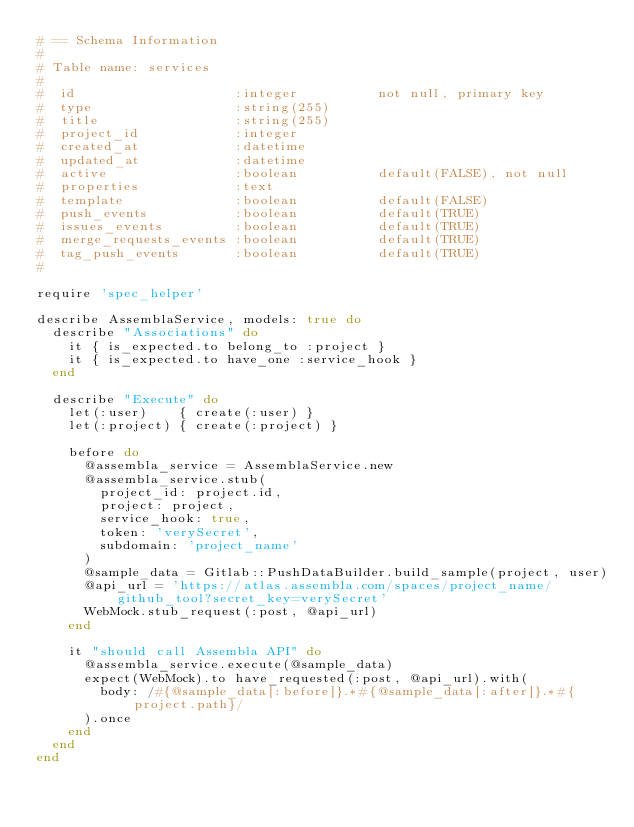<code> <loc_0><loc_0><loc_500><loc_500><_Ruby_># == Schema Information
#
# Table name: services
#
#  id                    :integer          not null, primary key
#  type                  :string(255)
#  title                 :string(255)
#  project_id            :integer
#  created_at            :datetime
#  updated_at            :datetime
#  active                :boolean          default(FALSE), not null
#  properties            :text
#  template              :boolean          default(FALSE)
#  push_events           :boolean          default(TRUE)
#  issues_events         :boolean          default(TRUE)
#  merge_requests_events :boolean          default(TRUE)
#  tag_push_events       :boolean          default(TRUE)
#

require 'spec_helper'

describe AssemblaService, models: true do
  describe "Associations" do
    it { is_expected.to belong_to :project }
    it { is_expected.to have_one :service_hook }
  end

  describe "Execute" do
    let(:user)    { create(:user) }
    let(:project) { create(:project) }

    before do
      @assembla_service = AssemblaService.new
      @assembla_service.stub(
        project_id: project.id,
        project: project,
        service_hook: true,
        token: 'verySecret',
        subdomain: 'project_name'
      )
      @sample_data = Gitlab::PushDataBuilder.build_sample(project, user)
      @api_url = 'https://atlas.assembla.com/spaces/project_name/github_tool?secret_key=verySecret'
      WebMock.stub_request(:post, @api_url)
    end

    it "should call Assembla API" do
      @assembla_service.execute(@sample_data)
      expect(WebMock).to have_requested(:post, @api_url).with(
        body: /#{@sample_data[:before]}.*#{@sample_data[:after]}.*#{project.path}/
      ).once
    end
  end
end
</code> 